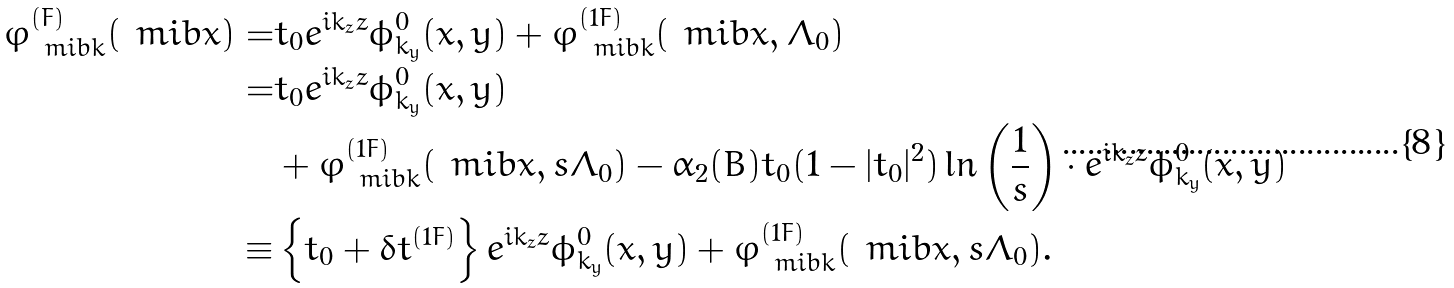Convert formula to latex. <formula><loc_0><loc_0><loc_500><loc_500>\varphi _ { \ m i b { k } } ^ { ( F ) } ( \ m i b { x } ) = & t _ { 0 } e ^ { i k _ { z } z } \phi _ { k _ { y } } ^ { 0 } ( x , y ) + \varphi _ { \ m i b { k } } ^ { ( 1 F ) } ( \ m i b { x } , \Lambda _ { 0 } ) \\ = & t _ { 0 } e ^ { i k _ { z } z } \phi _ { k _ { y } } ^ { 0 } ( x , y ) \\ & + \varphi _ { \ m i b { k } } ^ { ( 1 F ) } ( \ m i b { x } , s \Lambda _ { 0 } ) - \alpha _ { 2 } ( B ) t _ { 0 } ( 1 - | t _ { 0 } | ^ { 2 } ) \ln \left ( \frac { 1 } { s } \right ) \cdot e ^ { i k _ { z } z } \phi _ { k _ { y } } ^ { 0 } ( x , y ) \\ \equiv & \left \{ t _ { 0 } + \delta t ^ { ( 1 F ) } \right \} e ^ { i k _ { z } z } \phi _ { k _ { y } } ^ { 0 } ( x , y ) + \varphi _ { \ m i b { k } } ^ { ( 1 F ) } ( \ m i b { x } , s \Lambda _ { 0 } ) .</formula> 